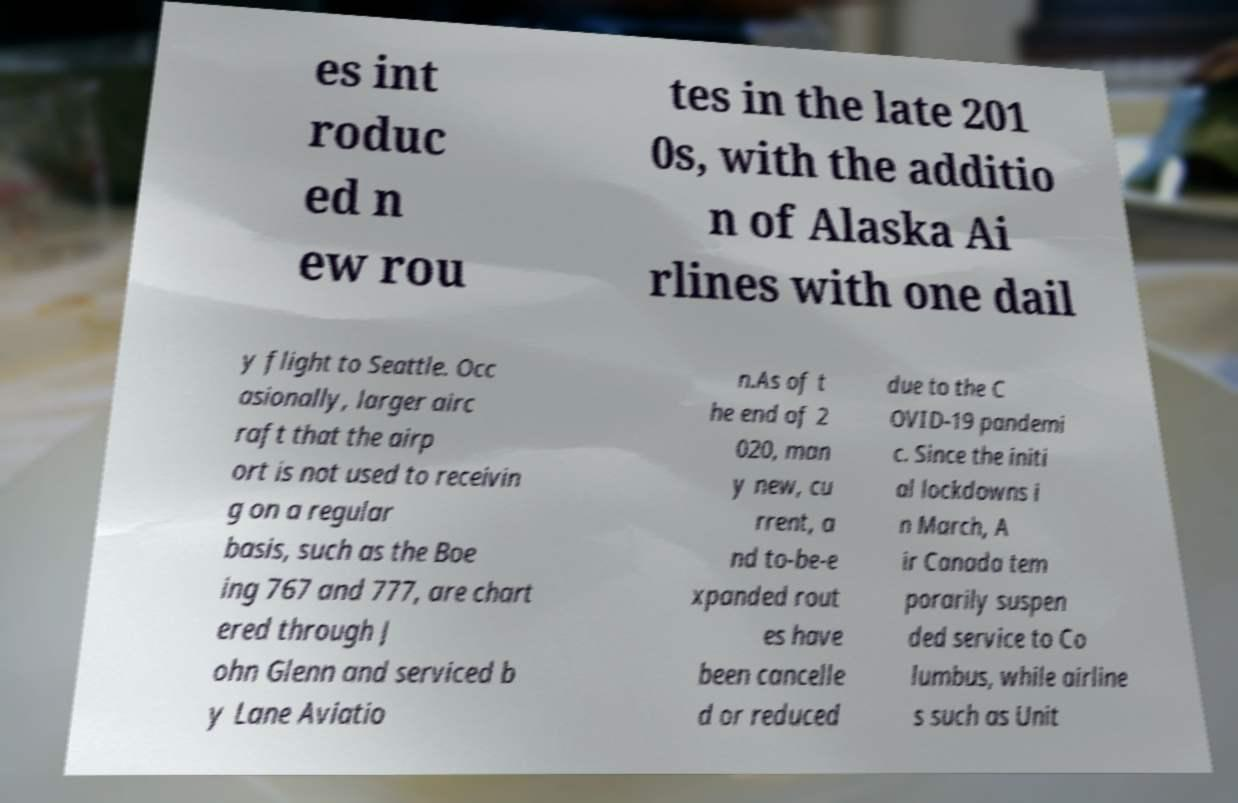Please read and relay the text visible in this image. What does it say? es int roduc ed n ew rou tes in the late 201 0s, with the additio n of Alaska Ai rlines with one dail y flight to Seattle. Occ asionally, larger airc raft that the airp ort is not used to receivin g on a regular basis, such as the Boe ing 767 and 777, are chart ered through J ohn Glenn and serviced b y Lane Aviatio n.As of t he end of 2 020, man y new, cu rrent, a nd to-be-e xpanded rout es have been cancelle d or reduced due to the C OVID-19 pandemi c. Since the initi al lockdowns i n March, A ir Canada tem porarily suspen ded service to Co lumbus, while airline s such as Unit 